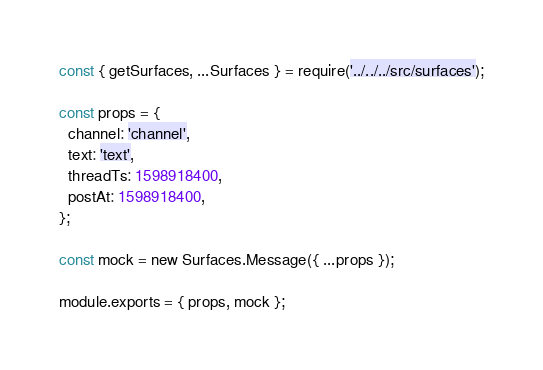Convert code to text. <code><loc_0><loc_0><loc_500><loc_500><_JavaScript_>const { getSurfaces, ...Surfaces } = require('../../../src/surfaces');

const props = {
  channel: 'channel',
  text: 'text',
  threadTs: 1598918400,
  postAt: 1598918400,
};

const mock = new Surfaces.Message({ ...props });

module.exports = { props, mock };
</code> 